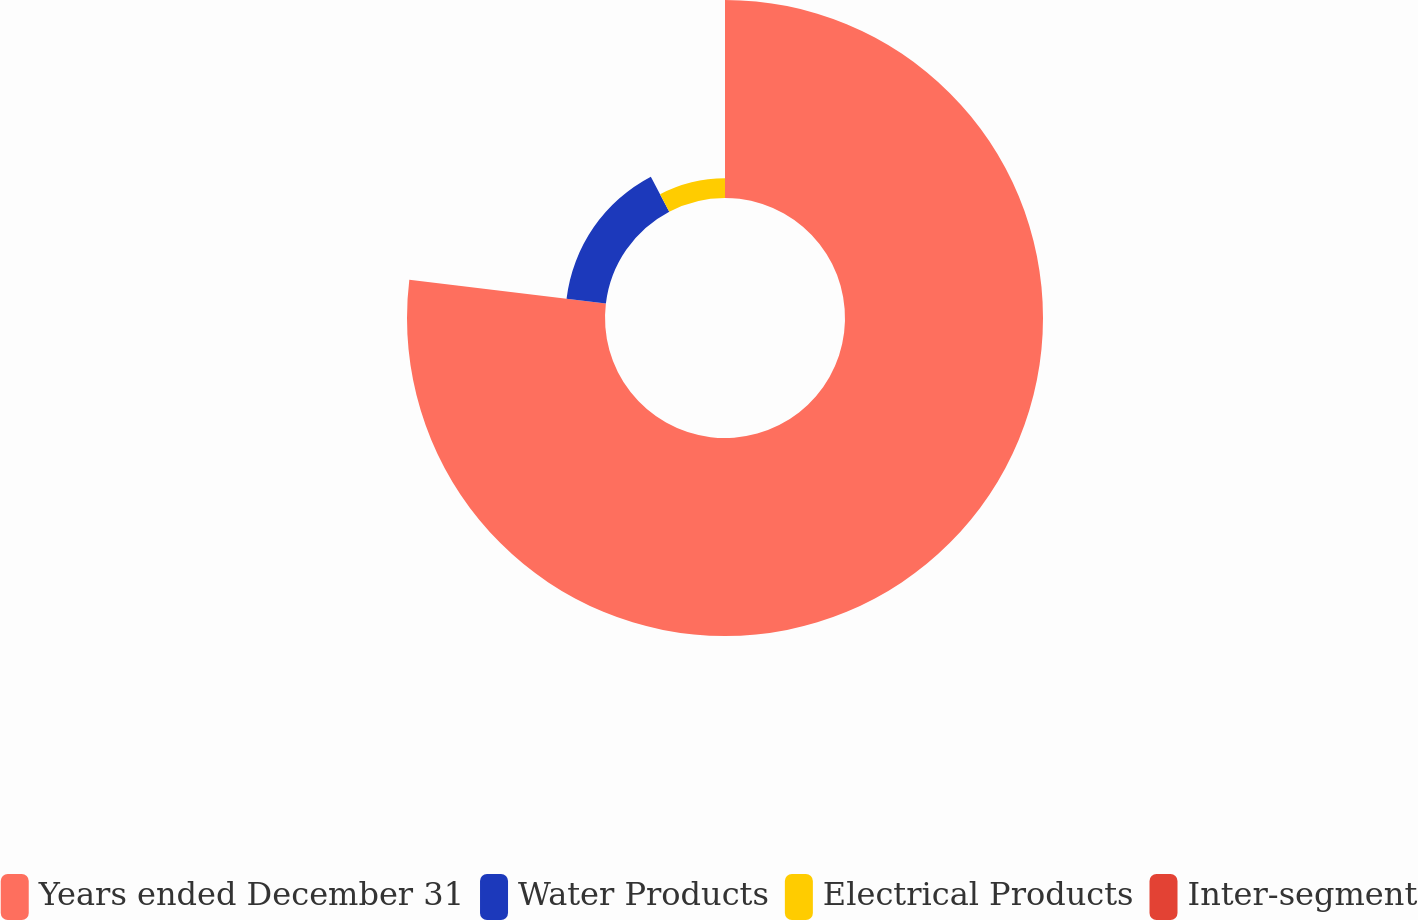Convert chart to OTSL. <chart><loc_0><loc_0><loc_500><loc_500><pie_chart><fcel>Years ended December 31<fcel>Water Products<fcel>Electrical Products<fcel>Inter-segment<nl><fcel>76.92%<fcel>15.39%<fcel>7.69%<fcel>0.0%<nl></chart> 